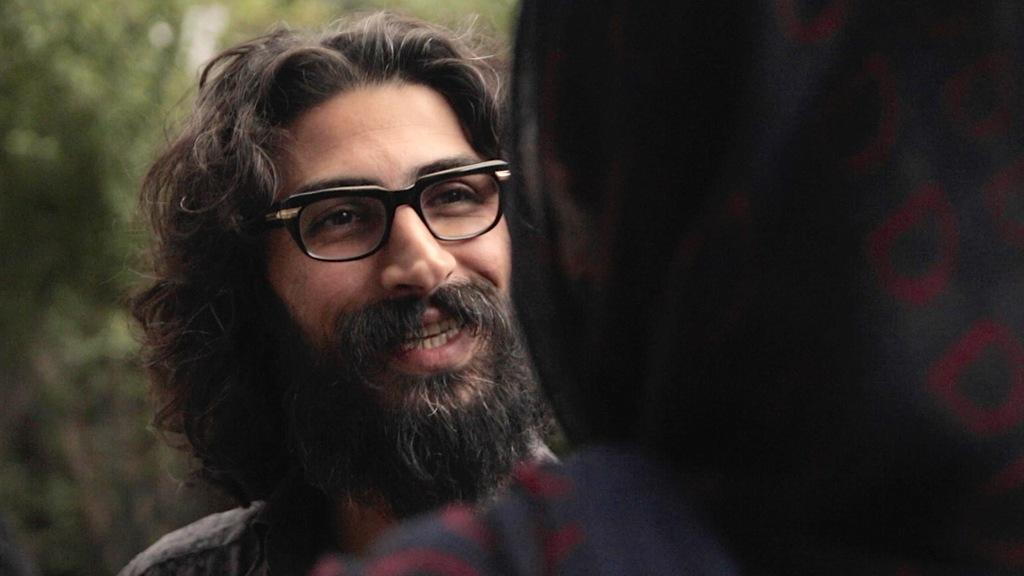What is the main subject of the image? There is a man in the image. What is the man doing in the image? The man is smiling in the image. Can you describe the background of the image? The background of the image appears green. Is there anyone else in the image besides the man? It is less certain due to the ambiguity in the transcript, but there might be a person on the right side of the image. What type of engine can be seen in the image? There is no engine present in the image. How does the corn appear in the image? There is no corn present in the image. 